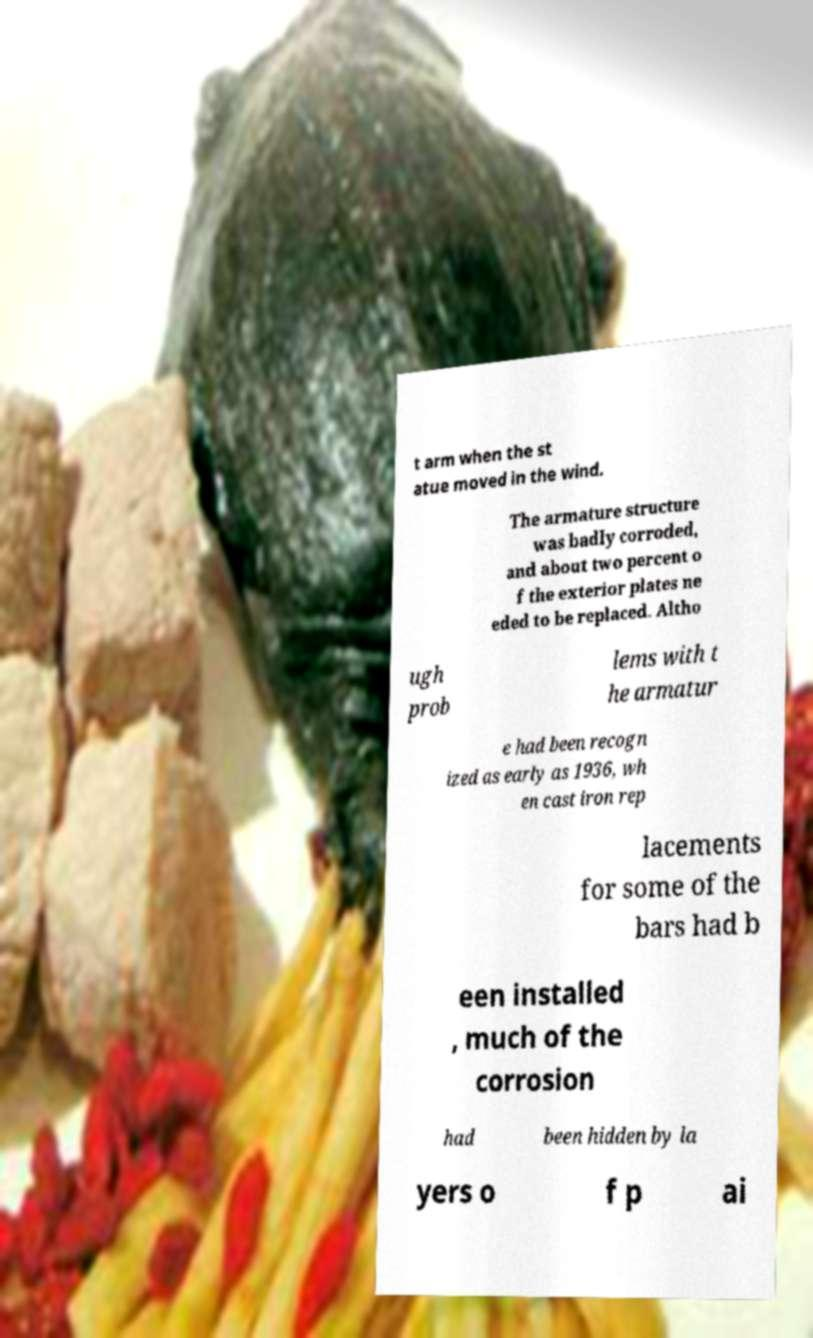Can you accurately transcribe the text from the provided image for me? t arm when the st atue moved in the wind. The armature structure was badly corroded, and about two percent o f the exterior plates ne eded to be replaced. Altho ugh prob lems with t he armatur e had been recogn ized as early as 1936, wh en cast iron rep lacements for some of the bars had b een installed , much of the corrosion had been hidden by la yers o f p ai 